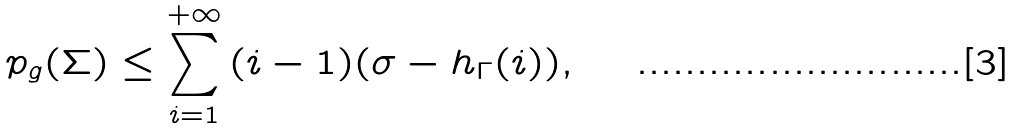<formula> <loc_0><loc_0><loc_500><loc_500>p _ { g } ( \Sigma ) \leq \sum _ { i = 1 } ^ { + \infty } { ( i - 1 ) } ( \sigma - h _ { \Gamma } ( i ) ) ,</formula> 